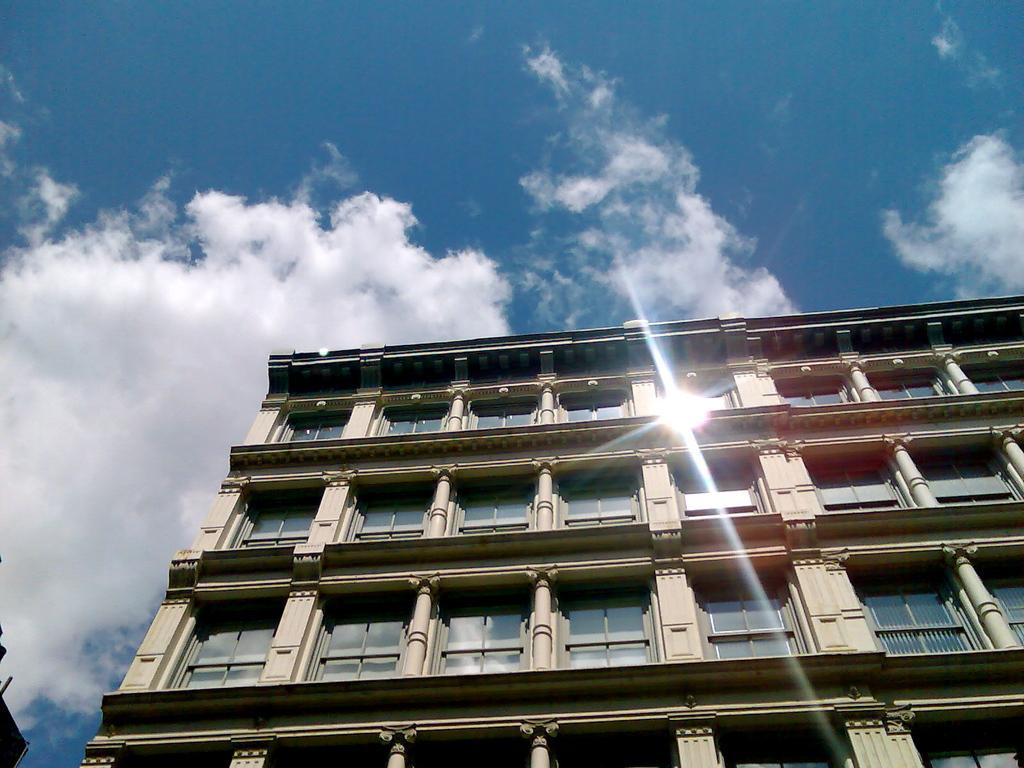How would you summarize this image in a sentence or two? In this image I can see the building with windows and railing. In the background I can see the clouds and the blue sky. 